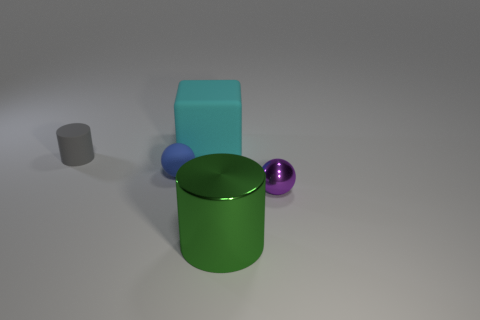How many balls are matte objects or small purple metal things?
Give a very brief answer. 2. There is a tiny object in front of the blue rubber ball; is it the same shape as the large green thing?
Your answer should be very brief. No. Is the number of shiny things to the right of the small purple metal object greater than the number of large purple cylinders?
Keep it short and to the point. No. The rubber ball that is the same size as the purple shiny thing is what color?
Your answer should be compact. Blue. How many objects are tiny spheres that are to the right of the big cylinder or large blue spheres?
Your answer should be compact. 1. What is the material of the big object that is in front of the tiny sphere to the right of the big green object?
Your answer should be compact. Metal. Are there any large red cylinders made of the same material as the green cylinder?
Give a very brief answer. No. Are there any gray cylinders in front of the sphere to the left of the cyan cube?
Provide a succinct answer. No. There is a thing that is right of the big green metal cylinder; what is it made of?
Keep it short and to the point. Metal. Is the big cyan thing the same shape as the gray object?
Provide a succinct answer. No. 